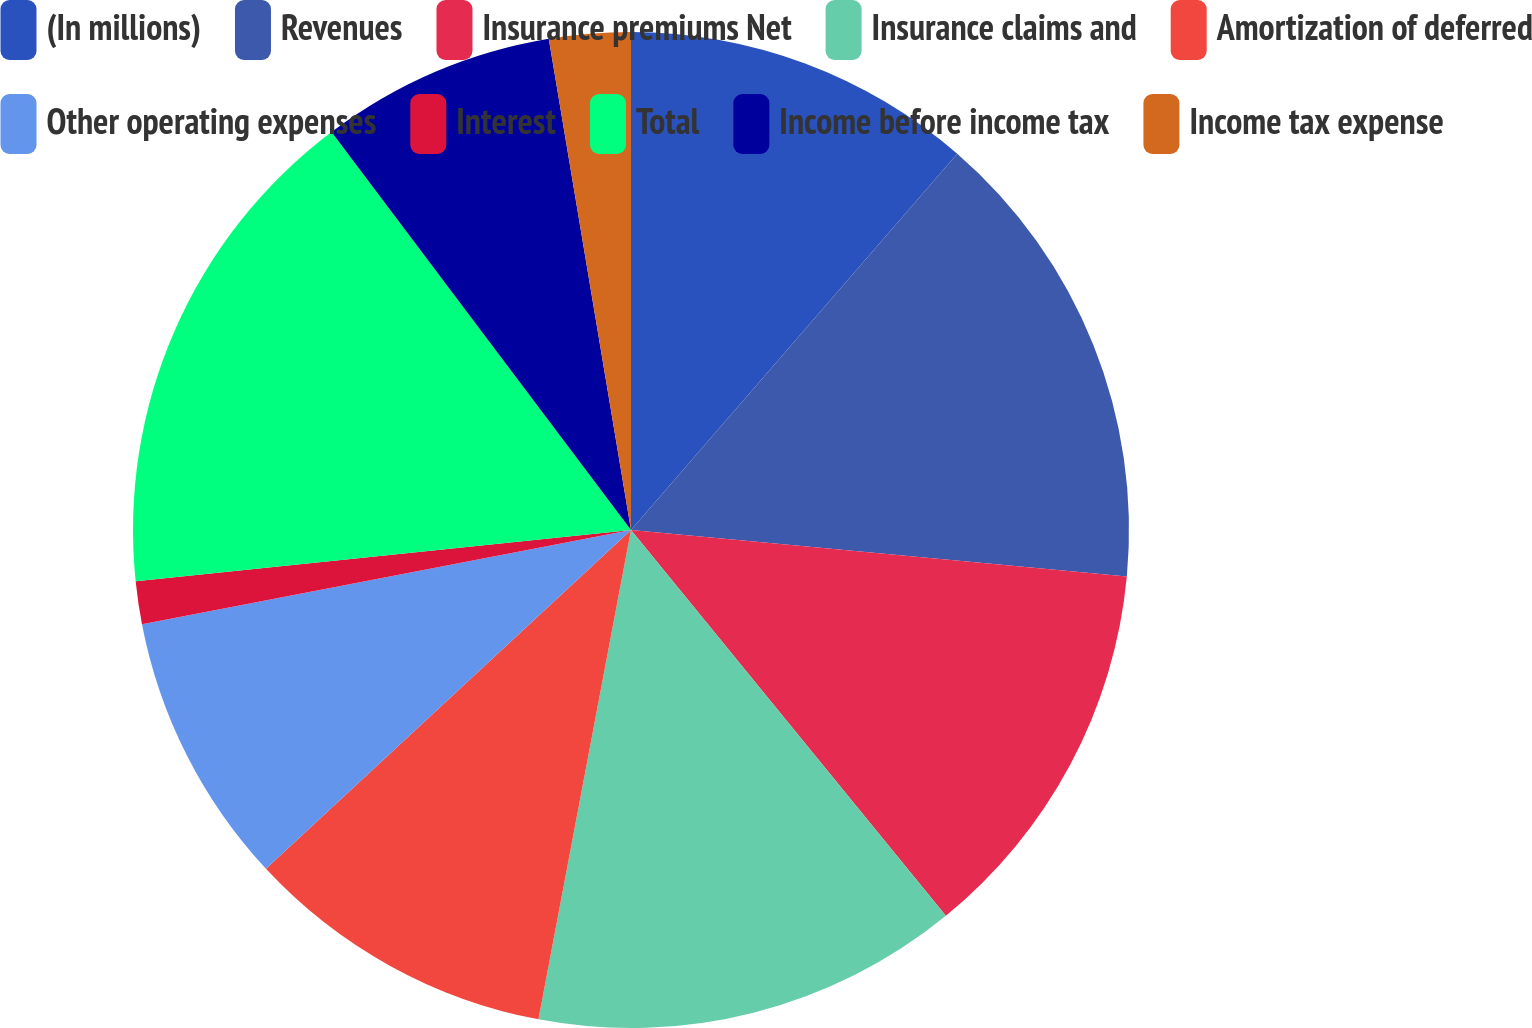Convert chart to OTSL. <chart><loc_0><loc_0><loc_500><loc_500><pie_chart><fcel>(In millions)<fcel>Revenues<fcel>Insurance premiums Net<fcel>Insurance claims and<fcel>Amortization of deferred<fcel>Other operating expenses<fcel>Interest<fcel>Total<fcel>Income before income tax<fcel>Income tax expense<nl><fcel>11.37%<fcel>15.12%<fcel>12.62%<fcel>13.87%<fcel>10.12%<fcel>8.88%<fcel>1.39%<fcel>16.37%<fcel>7.63%<fcel>2.64%<nl></chart> 